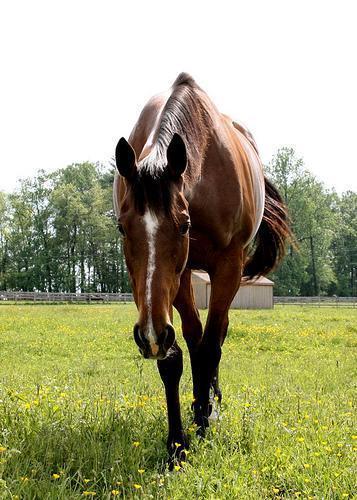How many horses?
Give a very brief answer. 1. 